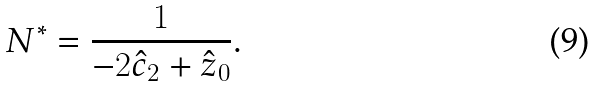<formula> <loc_0><loc_0><loc_500><loc_500>N ^ { * } = \frac { 1 } { - 2 \hat { c } _ { 2 } + \hat { z } _ { 0 } } .</formula> 